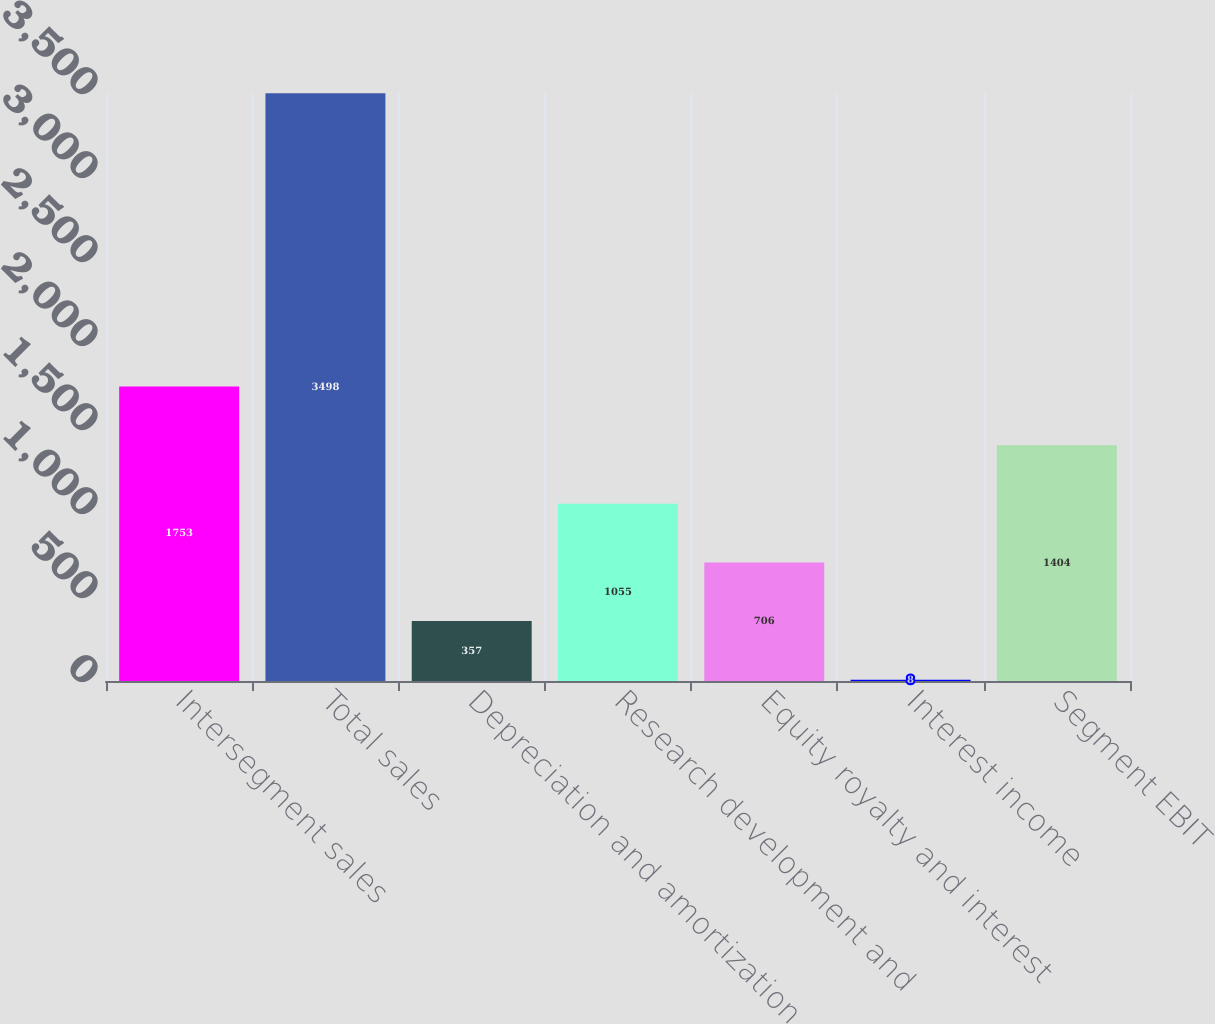Convert chart to OTSL. <chart><loc_0><loc_0><loc_500><loc_500><bar_chart><fcel>Intersegment sales<fcel>Total sales<fcel>Depreciation and amortization<fcel>Research development and<fcel>Equity royalty and interest<fcel>Interest income<fcel>Segment EBIT<nl><fcel>1753<fcel>3498<fcel>357<fcel>1055<fcel>706<fcel>8<fcel>1404<nl></chart> 